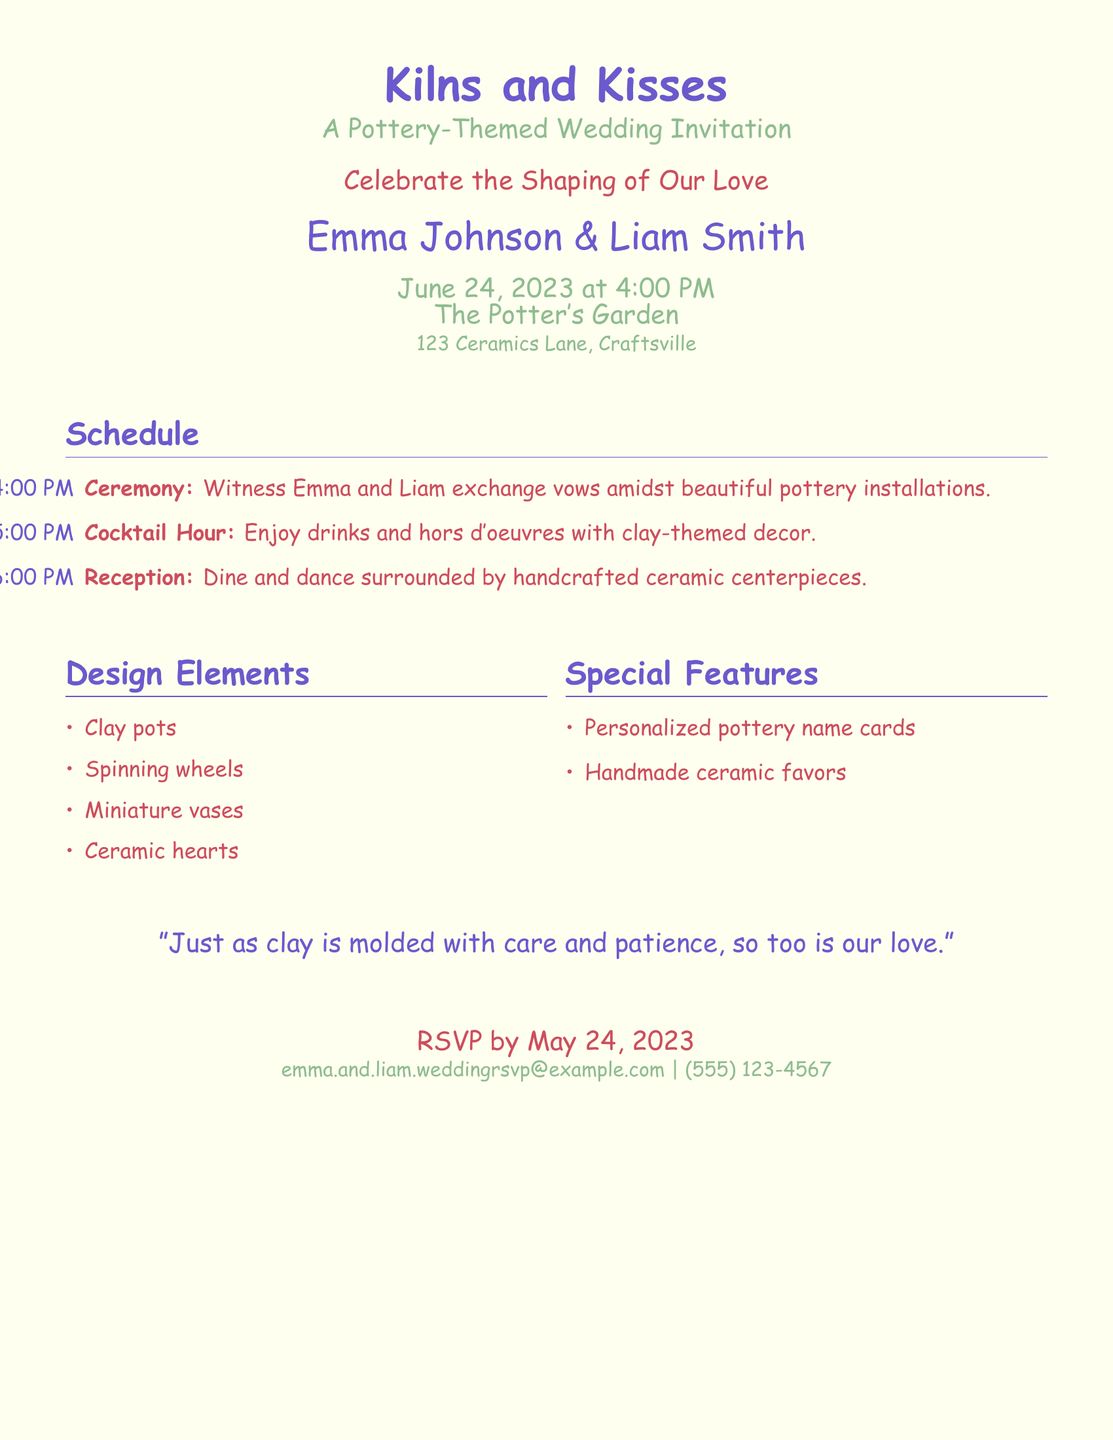what are the names of the couple? The couple’s names are prominently displayed at the top of the invitation.
Answer: Emma Johnson & Liam Smith when is the wedding date? The wedding date is listed clearly in the schedule section.
Answer: June 24, 2023 what time does the ceremony start? The start time for the ceremony is indicated in the schedule section.
Answer: 4:00 PM what is the venue for the wedding? The venue name is mentioned with the address in the invitation.
Answer: The Potter's Garden what color is used for the title? The title of the invitation is presented in a specific color.
Answer: Slateblue what type of decor is featured during the Cocktail Hour? The decor for the Cocktail Hour is described in the schedule.
Answer: Clay-themed decor what special feature is provided for guests? The invitation mentions unique offerings for guests that showcase the theme.
Answer: Handmade ceramic favors what is the RSVP date? The RSVP date is indicated at the bottom of the invitation.
Answer: May 24, 2023 what philosophy is quoted in the invitation? A quote that relates to the couple's theme is included towards the end.
Answer: "Just as clay is molded with care and patience, so too is our love." 